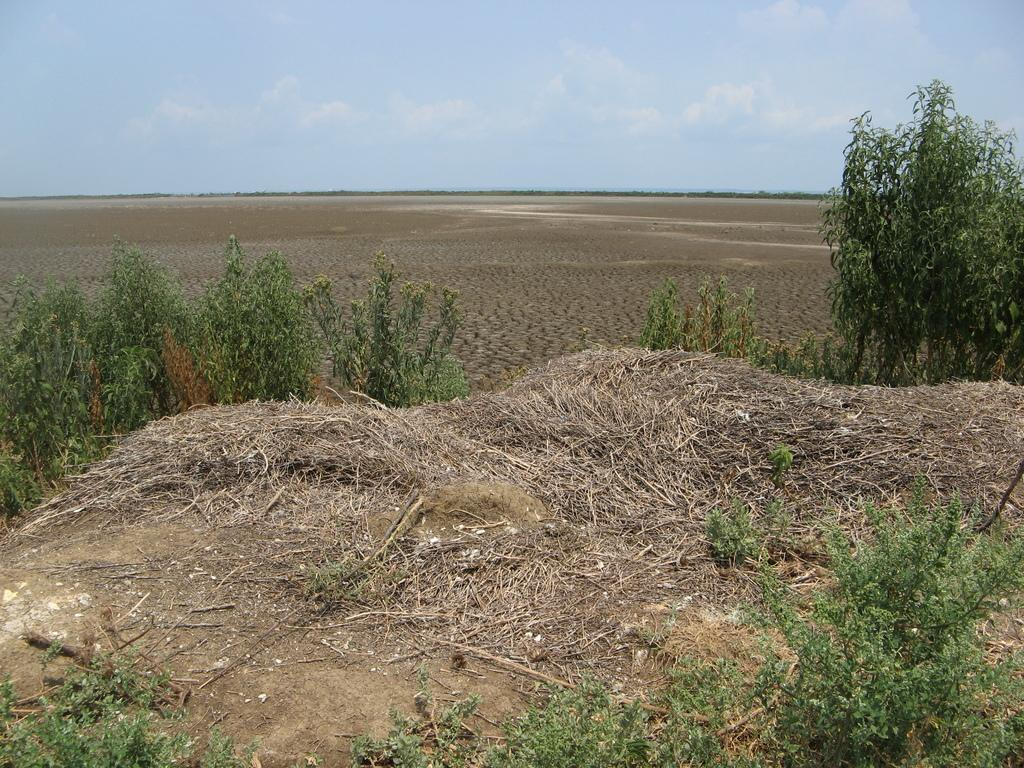What type of living organisms can be seen in the image? Plants can be seen in the image. What material are the sticks made of in the image? The sticks in the image are made of wood. What is visible at the bottom of the image? The ground is visible in the image. What is visible in the background of the image? The sky is visible in the background of the image. How does the icicle provide grip in the image? There is no icicle present in the image, so it cannot provide grip. 